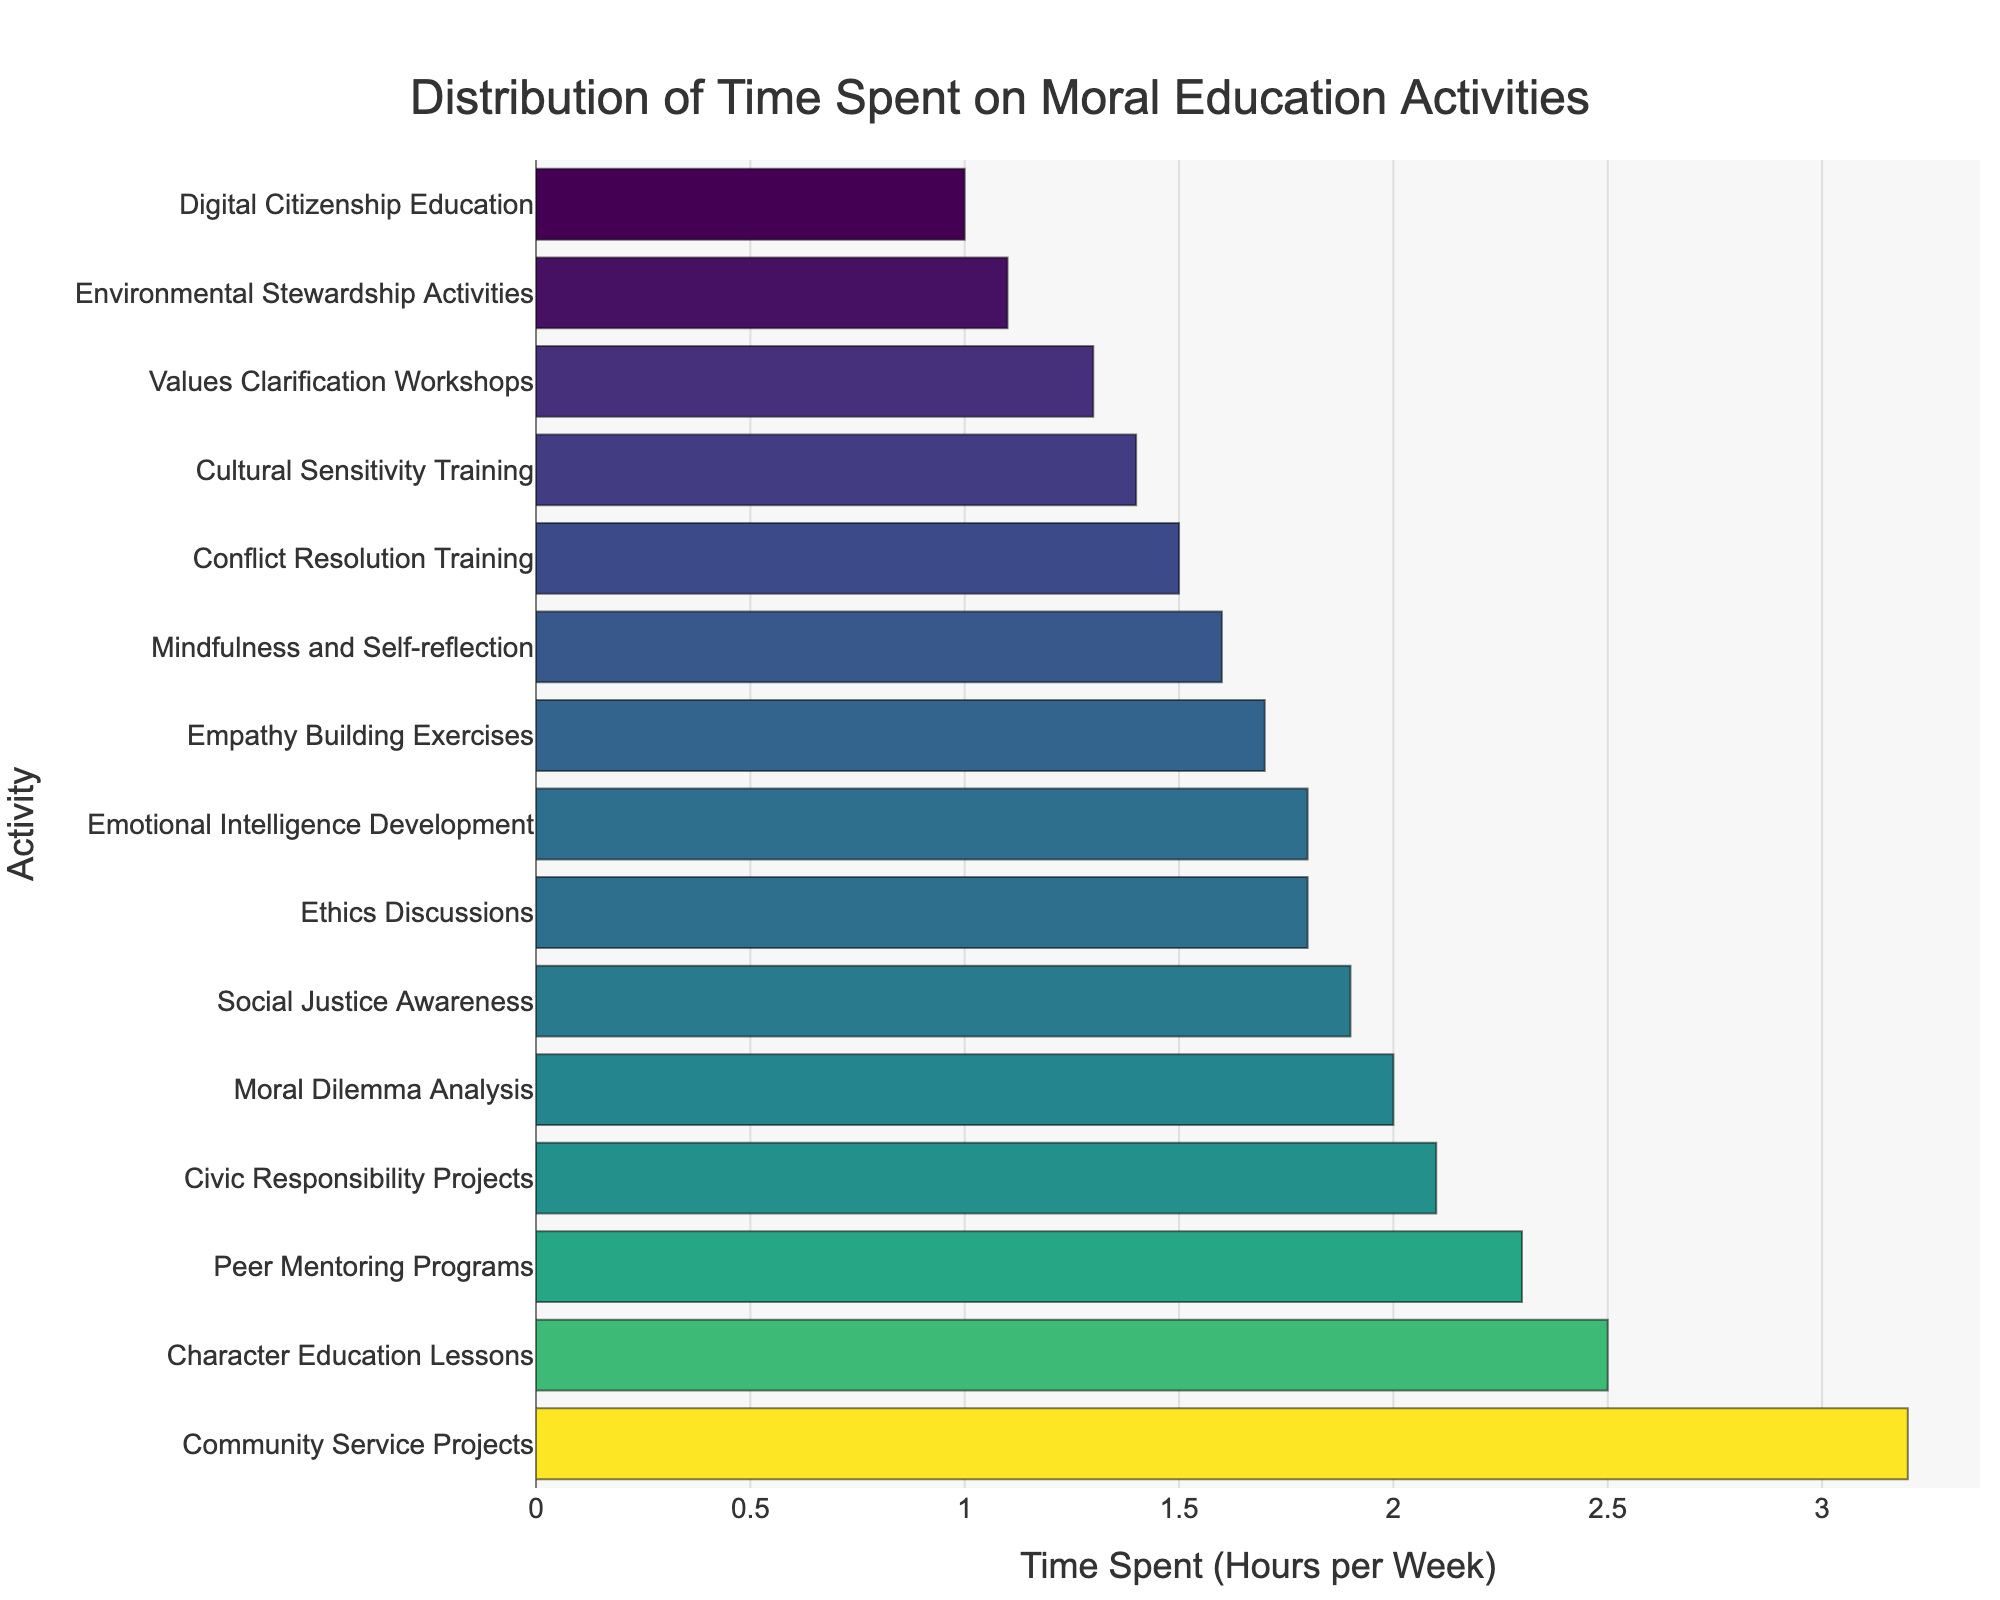What activity has the largest amount of time spent per week? The bar chart visually shows that Community Service Projects has the longest bar, indicating the most time spent.
Answer: Community Service Projects Which two activities have the closest amount of time spent per week and what are those times? Observing the lengths of the bars, Empathy Building Exercises and Mindfulness and Self-reflection are very close in length. Empathy Building Exercises is at 1.7 hours and Mindfulness and Self-Reflection is at 1.6 hours.
Answer: Empathy Building Exercises (1.7 hours) and Mindfulness and Self-reflection (1.6 hours) What is the total amount of time spent on Character Education Lessons and Peer Mentoring Programs per week? The bar for Character Education Lessons represents 2.5 hours and the bar for Peer Mentoring Programs represents 2.3 hours. Adding these two gives 2.5 + 2.3 = 4.8 hours.
Answer: 4.8 hours Which activity has less time spent, Conflict Resolution Training or Cultural Sensitivity Training, and by how much? The bar for Cultural Sensitivity Training is longer, indicating more time spent. Conflict Resolution Training has 1.5 hours, whereas Cultural Sensitivity Training has 1.4 hours. The difference is 1.5 - 1.4 = 0.1 hours.
Answer: Cultural Sensitivity Training by 0.1 hours How much more time is spent on Social Justice Awareness compared to Environmental Stewardship Activities? The bar for Social Justice Awareness shows 1.9 hours and Environmental Stewardship Activities shows 1.1 hours. The difference is 1.9 - 1.1 = 0.8 hours.
Answer: 0.8 hours Rank the top three activities based on time spent. Observing the lengths of the bars descending, the top three activities are Community Service Projects (3.2 hours), Character Education Lessons (2.5 hours), and Peer Mentoring Programs (2.3 hours).
Answer: 1. Community Service Projects, 2. Character Education Lessons, 3. Peer Mentoring Programs What is the average amount of time spent on Moral Dilemma Analysis, Values Clarification Workshops, and Digital Citizenship Education? The bars show Moral Dilemma Analysis (2.0 hours), Values Clarification Workshops (1.3 hours), and Digital Citizenship Education (1.0 hours). Their total is 2.0 + 1.3 + 1.0 = 4.3 hours. The average is 4.3 / 3 = 1.433 hours.
Answer: 1.433 hours Which activity has a mid-length bar and what is the time spent on it? Examining the chart, Conflict Resolution Training falls roughly in the middle. The length of its bar indicates 1.5 hours spent.
Answer: Conflict Resolution Training, 1.5 hours What is the total time spent on the three activities with the least time allocation? The least time allocation bars indicate Digital Citizenship Education (1.0 hours), Environmental Stewardship Activities (1.1 hours), and Values Clarification Workshops (1.3 hours). Their total is 1.0 + 1.1 + 1.3 = 3.4 hours.
Answer: 3.4 hours What percentage of time is spent on Civic Responsibility Projects out of the total time spent on all activities? Civic Responsibility Projects has 2.1 hours. The total time spent on all activities can be calculated by summing up all the times listed. Total = 2.5 + 1.8 + 3.2 + 1.5 + 2.0 + 1.7 + 1.3 + 1.9 + 1.6 + 2.3 + 1.4 + 1.1 + 1.0 + 1.8 + 2.1 = 26.2 hours. The percentage is (2.1 / 26.2) * 100 ≈ 8.02%.
Answer: 8.02% 